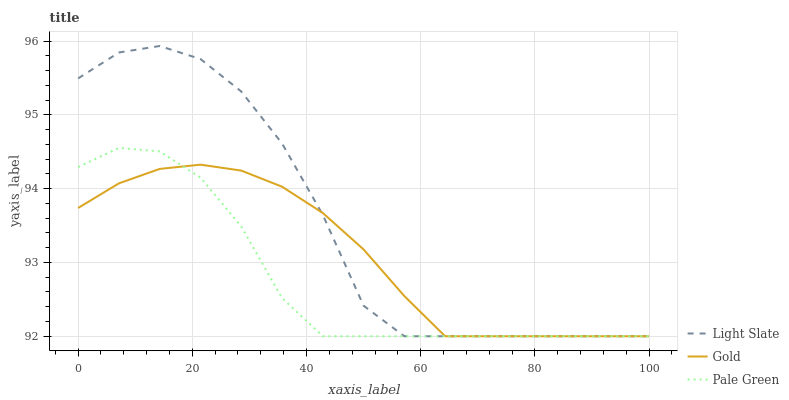Does Pale Green have the minimum area under the curve?
Answer yes or no. Yes. Does Light Slate have the maximum area under the curve?
Answer yes or no. Yes. Does Gold have the minimum area under the curve?
Answer yes or no. No. Does Gold have the maximum area under the curve?
Answer yes or no. No. Is Gold the smoothest?
Answer yes or no. Yes. Is Light Slate the roughest?
Answer yes or no. Yes. Is Pale Green the smoothest?
Answer yes or no. No. Is Pale Green the roughest?
Answer yes or no. No. Does Light Slate have the lowest value?
Answer yes or no. Yes. Does Light Slate have the highest value?
Answer yes or no. Yes. Does Pale Green have the highest value?
Answer yes or no. No. Does Gold intersect Light Slate?
Answer yes or no. Yes. Is Gold less than Light Slate?
Answer yes or no. No. Is Gold greater than Light Slate?
Answer yes or no. No. 